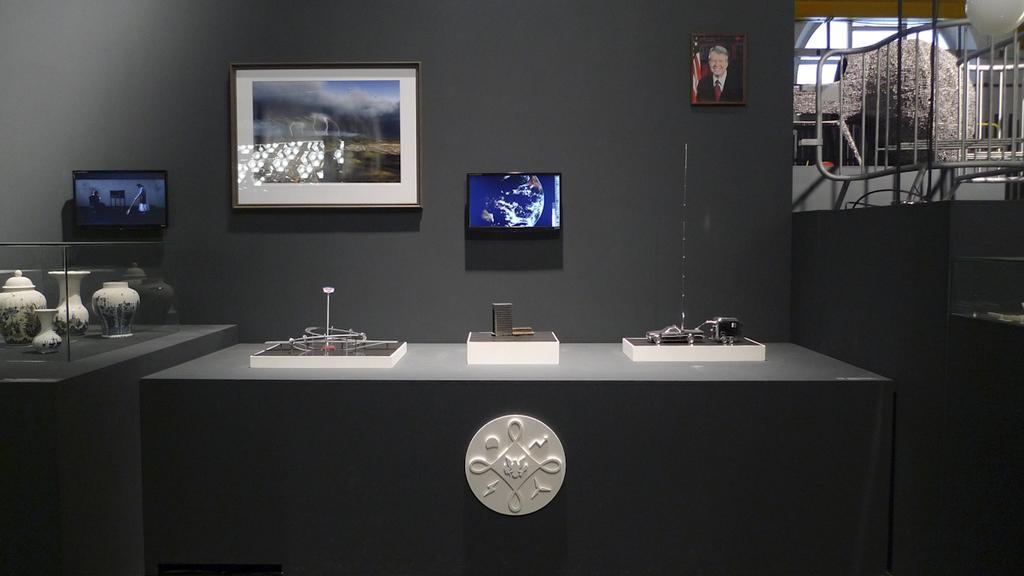In one or two sentences, can you explain what this image depicts? In this picture I can see there is a table, there is a logo on it, there are few objects placed on the table. There are few other objects placed in the glass box at left side. There are few photo frames arranged on the wall in the backdrop. There is a railing and an object placed on the right side. 